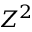Convert formula to latex. <formula><loc_0><loc_0><loc_500><loc_500>Z ^ { 2 }</formula> 